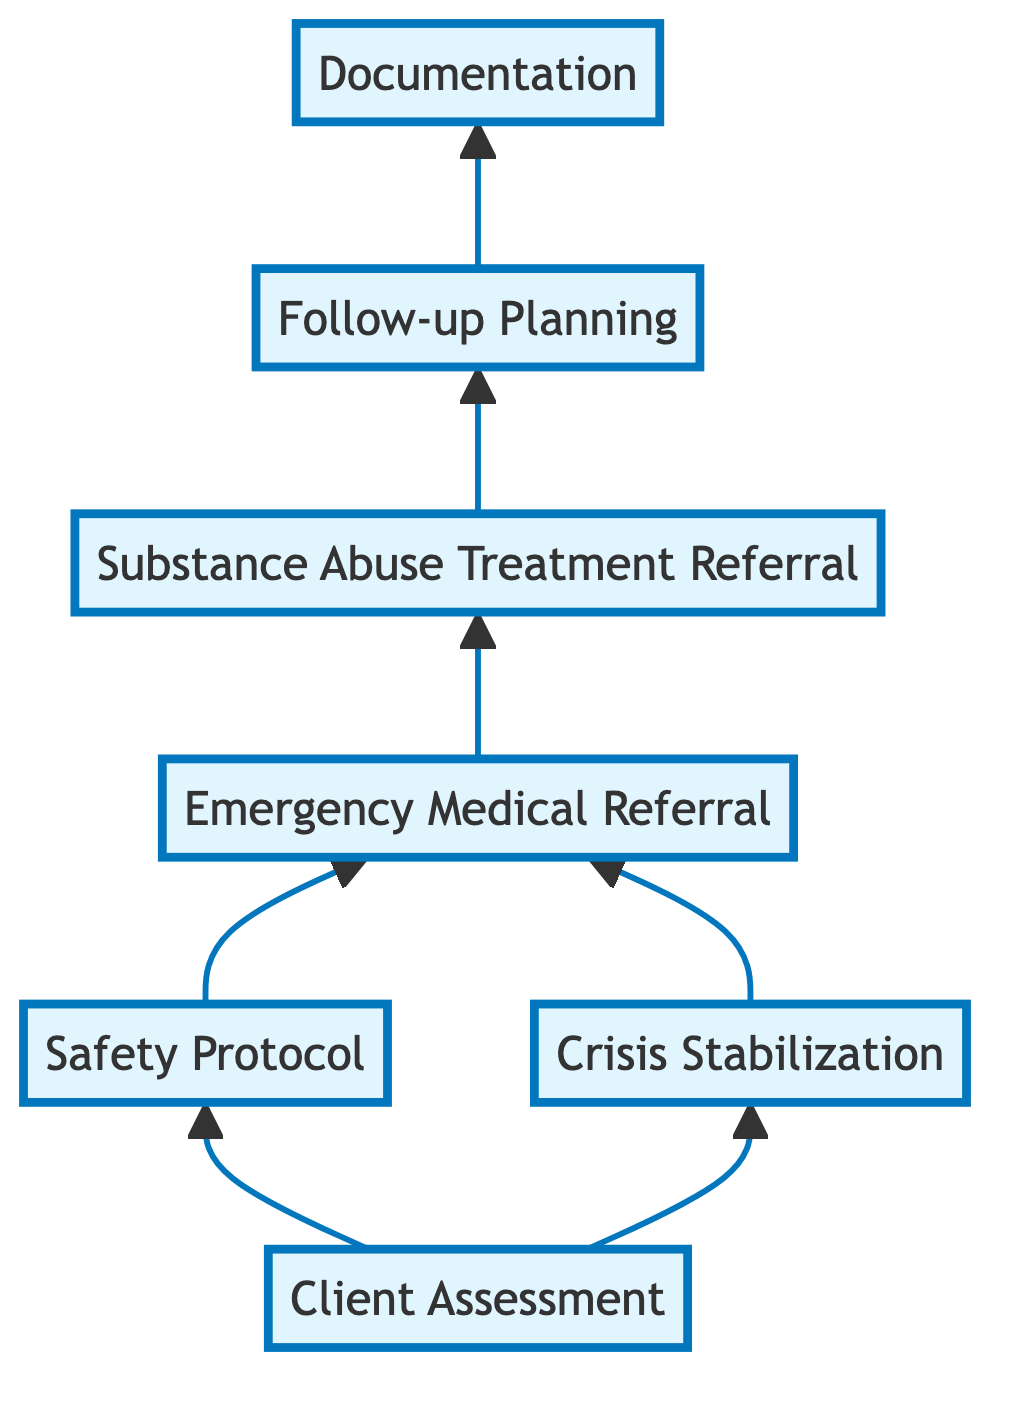What is the first step in the workflow? The first step in the workflow is "Client Assessment." This is indicated as the starting point in the flowchart where all processes initiate.
Answer: Client Assessment How many total steps are there in the intervention workflow? The workflow has a total of 7 distinct steps, counting from "Client Assessment" to "Documentation." Each unique labeled node in the chart represents one step.
Answer: 7 What step follows "Crisis Stabilization"? The step that follows "Crisis Stabilization" is "Emergency Medical Referral." The arrow from "Crisis Stabilization" leads directly to this next step in the diagram.
Answer: Emergency Medical Referral In the workflow, which steps lead to "Substance Abuse Treatment Referral"? Both "Emergency Medical Referral" and "Crisis Stabilization" lead to "Substance Abuse Treatment Referral," as both steps have arrows pointing to this node in the diagram.
Answer: Emergency Medical Referral, Crisis Stabilization What is documented after follow-up planning? After "Follow-up Planning," the next step is "Documentation." The flowchart shows an arrow leading directly to "Documentation" from "Follow-up Planning."
Answer: Documentation How many referral pathways connect to "Substance Abuse Treatment Referral"? There are 2 referral pathways that connect to "Substance Abuse Treatment Referral," originating from "Emergency Medical Referral" and "Crisis Stabilization."
Answer: 2 Which step requires evaluation of the client's status? "Client Assessment" is the step that requires evaluation of the client's current substance use, mental health status, and immediate needs, as described in its function within the workflow.
Answer: Client Assessment What is the purpose of the "Safety Protocol" step? The "Safety Protocol" step's purpose is to implement measures that protect the client and others from harm, as specified in its description within the flowchart.
Answer: Protect client and others from harm In what order do the steps occur leading from "Emergency Medical Referral"? The steps occur in the following order after "Emergency Medical Referral": "Substance Abuse Treatment Referral" followed by "Follow-up Planning" and then "Documentation." This is determined by tracing the arrows from "Emergency Medical Referral" to the subsequent nodes in the diagram.
Answer: Substance Abuse Treatment Referral, Follow-up Planning, Documentation 